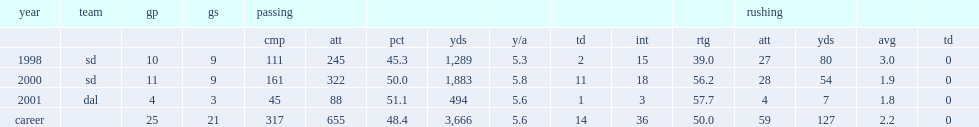How many passing yards did ryan leaf get in 2001? 494.0. 